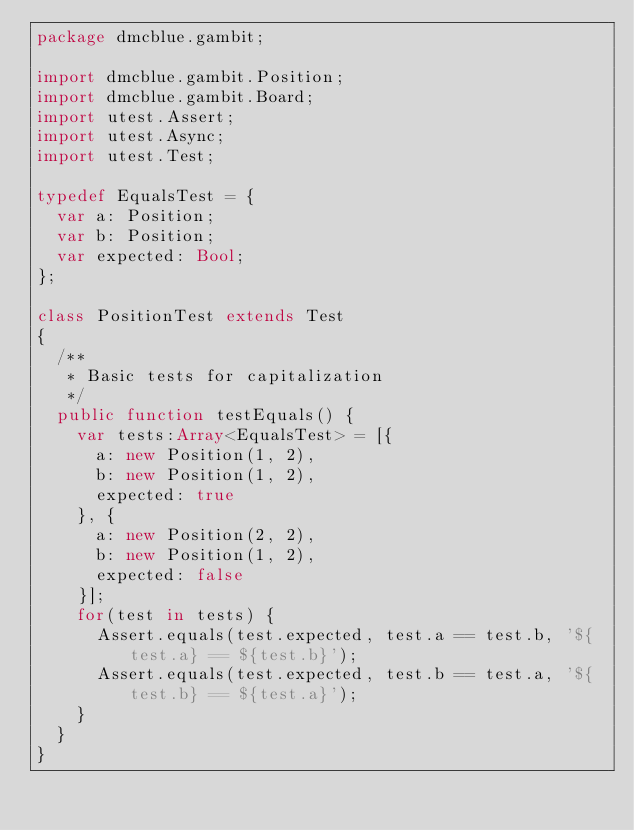<code> <loc_0><loc_0><loc_500><loc_500><_Haxe_>package dmcblue.gambit;

import dmcblue.gambit.Position;
import dmcblue.gambit.Board;
import utest.Assert;
import utest.Async;
import utest.Test;

typedef EqualsTest = {
	var a: Position;
	var b: Position;
	var expected: Bool;
};

class PositionTest extends Test 
{
	/**
	 * Basic tests for capitalization
	 */
	public function testEquals() {
		var tests:Array<EqualsTest> = [{
			a: new Position(1, 2),
			b: new Position(1, 2),
			expected: true
		}, {
			a: new Position(2, 2),
			b: new Position(1, 2),
			expected: false
		}];
		for(test in tests) {
			Assert.equals(test.expected, test.a == test.b, '${test.a} == ${test.b}');
			Assert.equals(test.expected, test.b == test.a, '${test.b} == ${test.a}');
		}
	}
}
</code> 